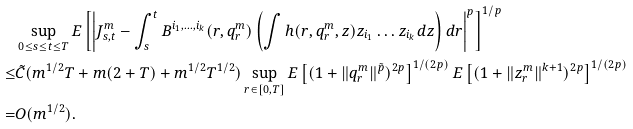Convert formula to latex. <formula><loc_0><loc_0><loc_500><loc_500>& \sup _ { 0 \leq s \leq t \leq T } E \left [ \left | J ^ { m } _ { s , t } - \int _ { s } ^ { t } B ^ { i _ { 1 } , \dots , i _ { k } } ( r , q ^ { m } _ { r } ) \left ( \int h ( r , q ^ { m } _ { r } , z ) z _ { i _ { 1 } } \dots z _ { i _ { k } } d z \right ) d r \right | ^ { p } \right ] ^ { 1 / p } \\ \leq & \tilde { C } ( m ^ { 1 / 2 } T + m ( 2 + T ) + m ^ { 1 / 2 } T ^ { 1 / 2 } ) \sup _ { r \in [ 0 , T ] } E \left [ ( 1 + \| q _ { r } ^ { m } \| ^ { \tilde { p } } ) ^ { 2 p } \right ] ^ { 1 / ( 2 p ) } E \left [ ( 1 + \| z _ { r } ^ { m } \| ^ { k + 1 } ) ^ { 2 p } \right ] ^ { 1 / ( 2 p ) } \\ = & O ( m ^ { 1 / 2 } ) .</formula> 